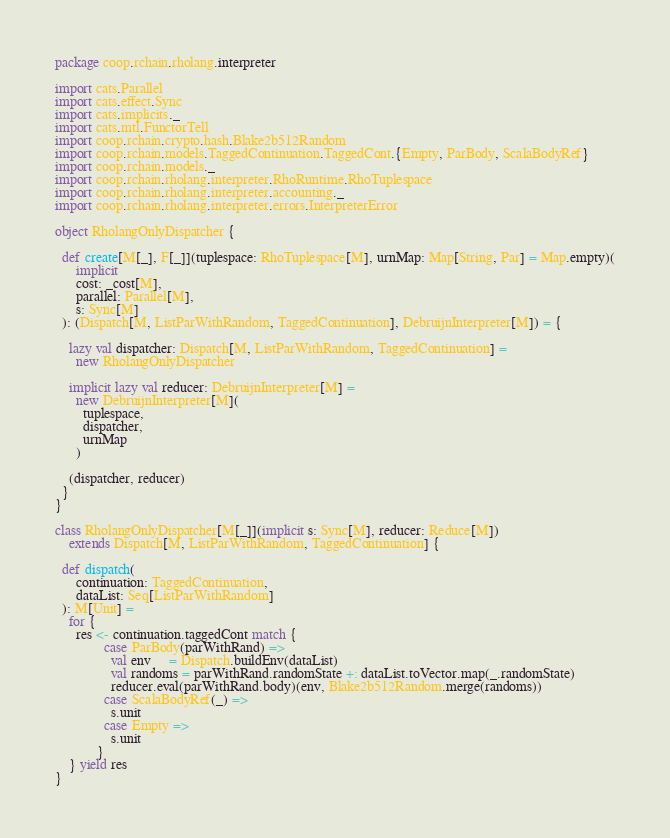Convert code to text. <code><loc_0><loc_0><loc_500><loc_500><_Scala_>package coop.rchain.rholang.interpreter

import cats.Parallel
import cats.effect.Sync
import cats.implicits._
import cats.mtl.FunctorTell
import coop.rchain.crypto.hash.Blake2b512Random
import coop.rchain.models.TaggedContinuation.TaggedCont.{Empty, ParBody, ScalaBodyRef}
import coop.rchain.models._
import coop.rchain.rholang.interpreter.RhoRuntime.RhoTuplespace
import coop.rchain.rholang.interpreter.accounting._
import coop.rchain.rholang.interpreter.errors.InterpreterError

object RholangOnlyDispatcher {

  def create[M[_], F[_]](tuplespace: RhoTuplespace[M], urnMap: Map[String, Par] = Map.empty)(
      implicit
      cost: _cost[M],
      parallel: Parallel[M],
      s: Sync[M]
  ): (Dispatch[M, ListParWithRandom, TaggedContinuation], DebruijnInterpreter[M]) = {

    lazy val dispatcher: Dispatch[M, ListParWithRandom, TaggedContinuation] =
      new RholangOnlyDispatcher

    implicit lazy val reducer: DebruijnInterpreter[M] =
      new DebruijnInterpreter[M](
        tuplespace,
        dispatcher,
        urnMap
      )

    (dispatcher, reducer)
  }
}

class RholangOnlyDispatcher[M[_]](implicit s: Sync[M], reducer: Reduce[M])
    extends Dispatch[M, ListParWithRandom, TaggedContinuation] {

  def dispatch(
      continuation: TaggedContinuation,
      dataList: Seq[ListParWithRandom]
  ): M[Unit] =
    for {
      res <- continuation.taggedCont match {
              case ParBody(parWithRand) =>
                val env     = Dispatch.buildEnv(dataList)
                val randoms = parWithRand.randomState +: dataList.toVector.map(_.randomState)
                reducer.eval(parWithRand.body)(env, Blake2b512Random.merge(randoms))
              case ScalaBodyRef(_) =>
                s.unit
              case Empty =>
                s.unit
            }
    } yield res
}
</code> 